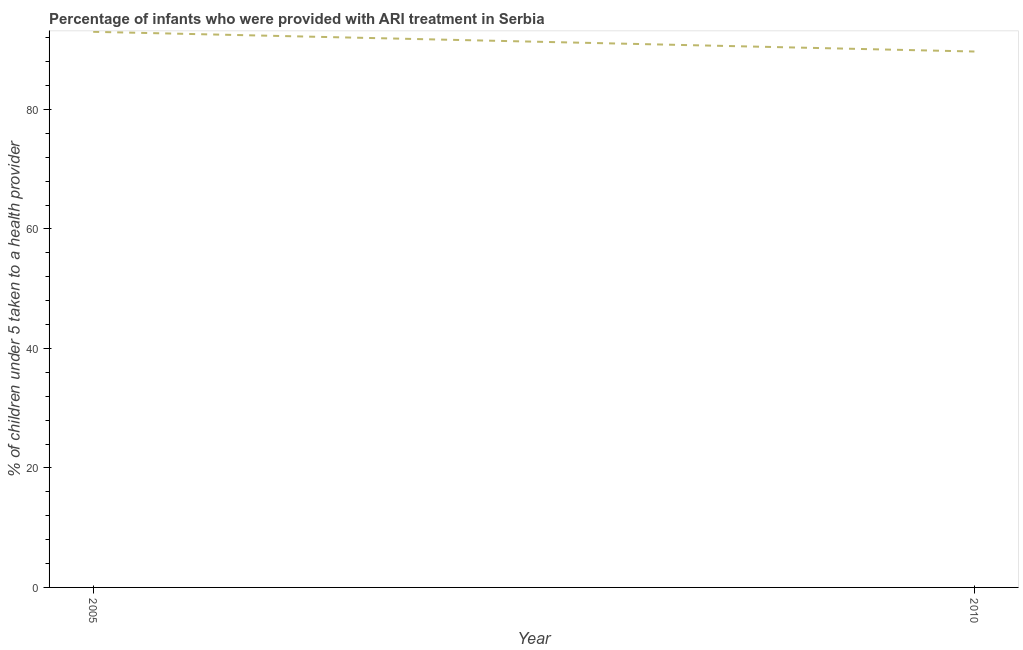What is the percentage of children who were provided with ari treatment in 2005?
Make the answer very short. 93. Across all years, what is the maximum percentage of children who were provided with ari treatment?
Your response must be concise. 93. Across all years, what is the minimum percentage of children who were provided with ari treatment?
Ensure brevity in your answer.  89.7. In which year was the percentage of children who were provided with ari treatment maximum?
Your answer should be compact. 2005. What is the sum of the percentage of children who were provided with ari treatment?
Provide a short and direct response. 182.7. What is the difference between the percentage of children who were provided with ari treatment in 2005 and 2010?
Keep it short and to the point. 3.3. What is the average percentage of children who were provided with ari treatment per year?
Ensure brevity in your answer.  91.35. What is the median percentage of children who were provided with ari treatment?
Make the answer very short. 91.35. In how many years, is the percentage of children who were provided with ari treatment greater than 60 %?
Offer a terse response. 2. What is the ratio of the percentage of children who were provided with ari treatment in 2005 to that in 2010?
Ensure brevity in your answer.  1.04. In how many years, is the percentage of children who were provided with ari treatment greater than the average percentage of children who were provided with ari treatment taken over all years?
Provide a short and direct response. 1. Does the graph contain any zero values?
Provide a succinct answer. No. Does the graph contain grids?
Your answer should be very brief. No. What is the title of the graph?
Your answer should be compact. Percentage of infants who were provided with ARI treatment in Serbia. What is the label or title of the X-axis?
Your response must be concise. Year. What is the label or title of the Y-axis?
Your answer should be very brief. % of children under 5 taken to a health provider. What is the % of children under 5 taken to a health provider in 2005?
Ensure brevity in your answer.  93. What is the % of children under 5 taken to a health provider in 2010?
Your answer should be very brief. 89.7. What is the difference between the % of children under 5 taken to a health provider in 2005 and 2010?
Your answer should be very brief. 3.3. 